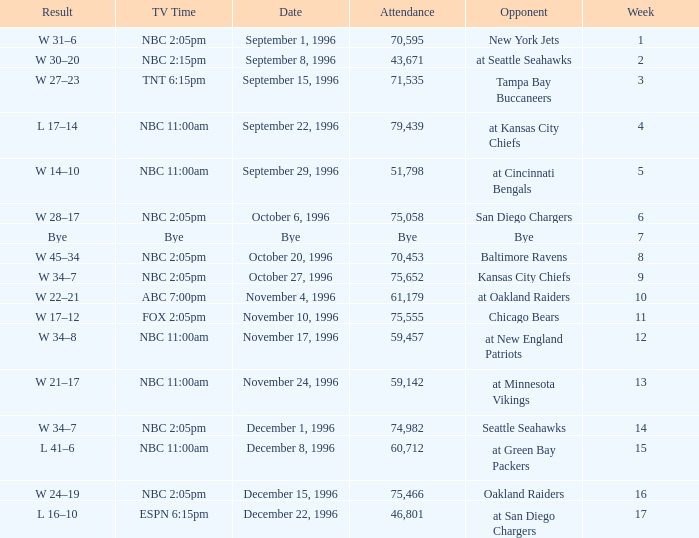WHAT IS THE TV TIME FOR NOVEMBER 10, 1996? FOX 2:05pm. Could you help me parse every detail presented in this table? {'header': ['Result', 'TV Time', 'Date', 'Attendance', 'Opponent', 'Week'], 'rows': [['W 31–6', 'NBC 2:05pm', 'September 1, 1996', '70,595', 'New York Jets', '1'], ['W 30–20', 'NBC 2:15pm', 'September 8, 1996', '43,671', 'at Seattle Seahawks', '2'], ['W 27–23', 'TNT 6:15pm', 'September 15, 1996', '71,535', 'Tampa Bay Buccaneers', '3'], ['L 17–14', 'NBC 11:00am', 'September 22, 1996', '79,439', 'at Kansas City Chiefs', '4'], ['W 14–10', 'NBC 11:00am', 'September 29, 1996', '51,798', 'at Cincinnati Bengals', '5'], ['W 28–17', 'NBC 2:05pm', 'October 6, 1996', '75,058', 'San Diego Chargers', '6'], ['Bye', 'Bye', 'Bye', 'Bye', 'Bye', '7'], ['W 45–34', 'NBC 2:05pm', 'October 20, 1996', '70,453', 'Baltimore Ravens', '8'], ['W 34–7', 'NBC 2:05pm', 'October 27, 1996', '75,652', 'Kansas City Chiefs', '9'], ['W 22–21', 'ABC 7:00pm', 'November 4, 1996', '61,179', 'at Oakland Raiders', '10'], ['W 17–12', 'FOX 2:05pm', 'November 10, 1996', '75,555', 'Chicago Bears', '11'], ['W 34–8', 'NBC 11:00am', 'November 17, 1996', '59,457', 'at New England Patriots', '12'], ['W 21–17', 'NBC 11:00am', 'November 24, 1996', '59,142', 'at Minnesota Vikings', '13'], ['W 34–7', 'NBC 2:05pm', 'December 1, 1996', '74,982', 'Seattle Seahawks', '14'], ['L 41–6', 'NBC 11:00am', 'December 8, 1996', '60,712', 'at Green Bay Packers', '15'], ['W 24–19', 'NBC 2:05pm', 'December 15, 1996', '75,466', 'Oakland Raiders', '16'], ['L 16–10', 'ESPN 6:15pm', 'December 22, 1996', '46,801', 'at San Diego Chargers', '17']]} 